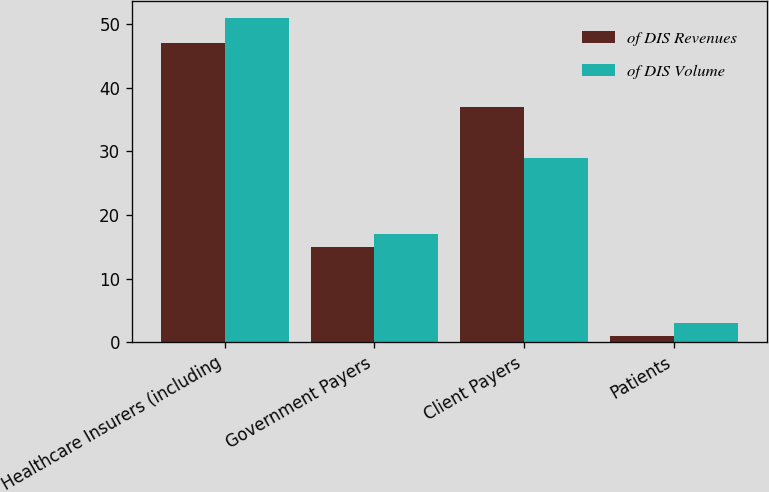Convert chart. <chart><loc_0><loc_0><loc_500><loc_500><stacked_bar_chart><ecel><fcel>Healthcare Insurers (including<fcel>Government Payers<fcel>Client Payers<fcel>Patients<nl><fcel>of DIS Revenues<fcel>47<fcel>15<fcel>37<fcel>1<nl><fcel>of DIS Volume<fcel>51<fcel>17<fcel>29<fcel>3<nl></chart> 